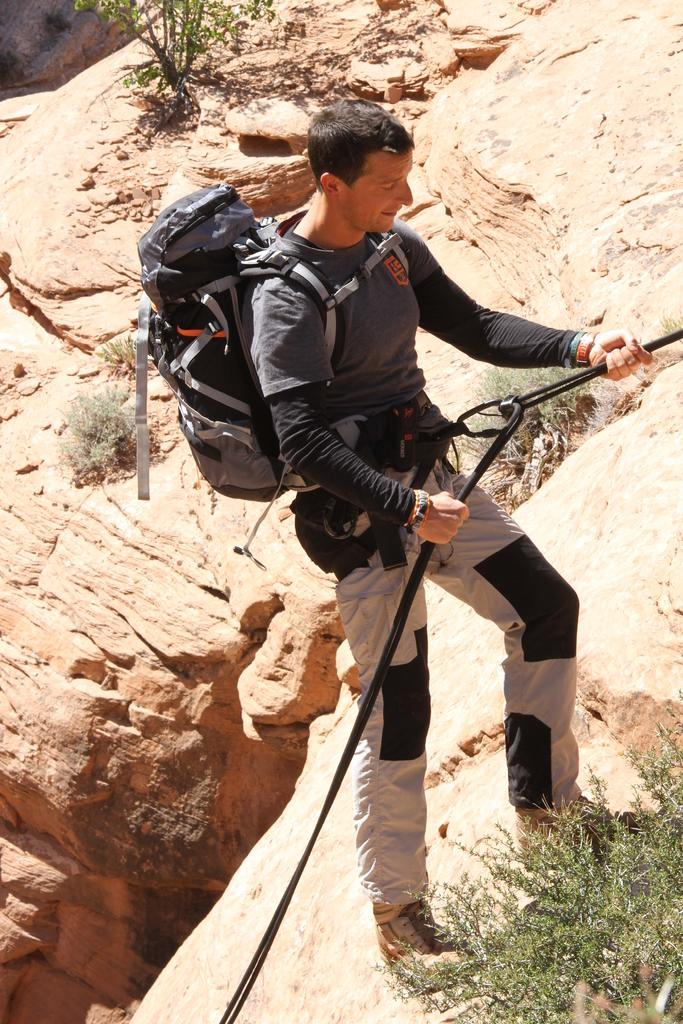Who is in the image? There is a man in the image. What is the man doing in the image? The man is climbing a mountain. What is the man carrying while climbing the mountain? The man is wearing a backpack. What can be seen at the bottom of the image? There is a small plant at the bottom of the image. What is visible in the background of the image? There are mountains and rocks in the background of the image. How does the man use his knowledge to water the plants in the image? There is no hose or any indication of watering plants in the image; the man is climbing a mountain with a backpack. 